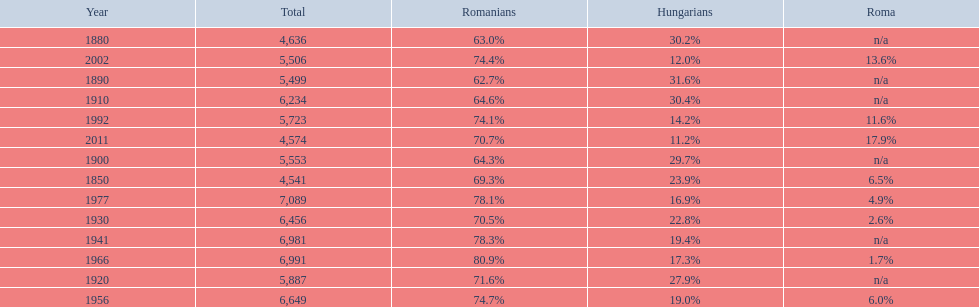In what year was there the largest percentage of hungarians? 1890. 